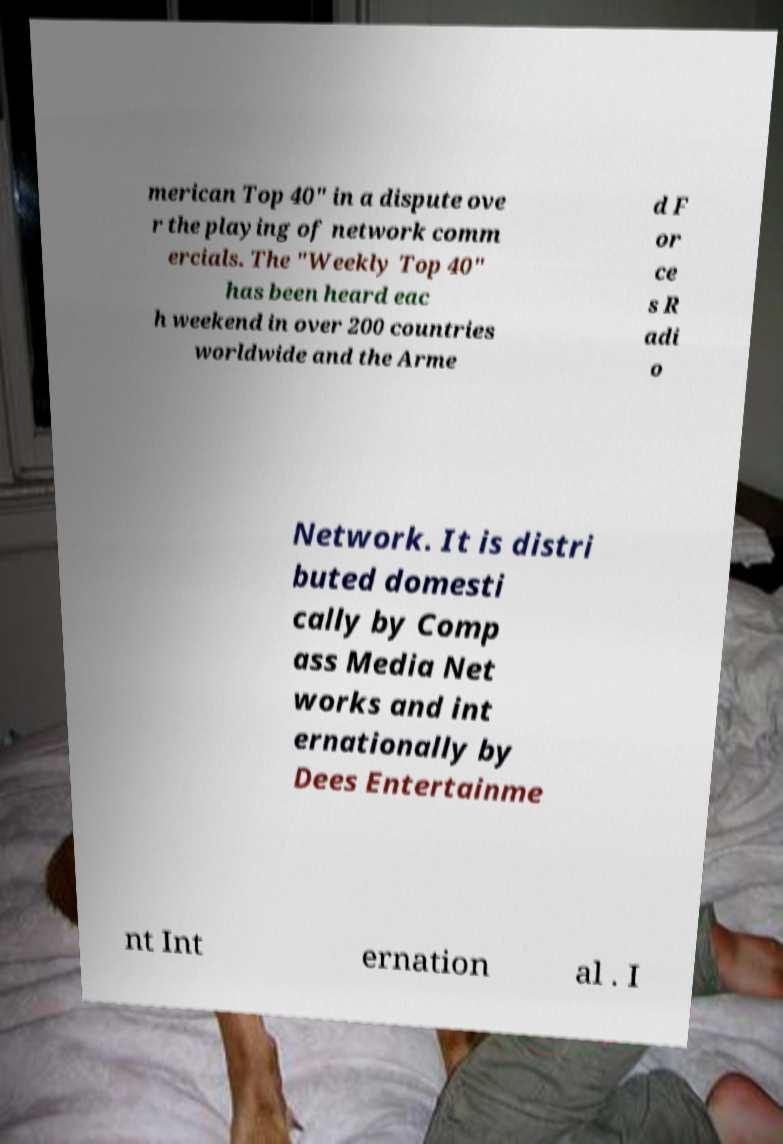For documentation purposes, I need the text within this image transcribed. Could you provide that? merican Top 40" in a dispute ove r the playing of network comm ercials. The "Weekly Top 40" has been heard eac h weekend in over 200 countries worldwide and the Arme d F or ce s R adi o Network. It is distri buted domesti cally by Comp ass Media Net works and int ernationally by Dees Entertainme nt Int ernation al . I 